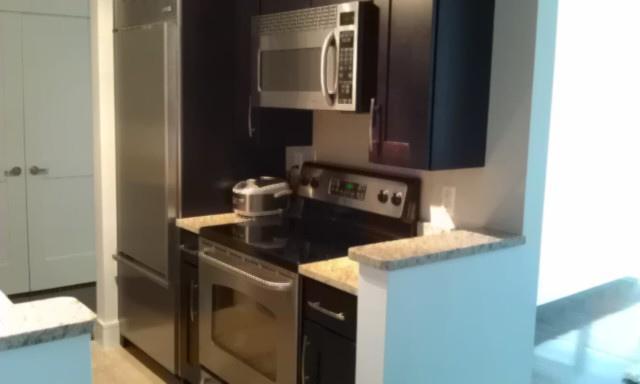What are the appliances made of?
Pick the right solution, then justify: 'Answer: answer
Rationale: rationale.'
Options: Glass, plastic, steel, wood. Answer: steel.
Rationale: The appliances are shiny. the material is metal, not plastic or wood. 